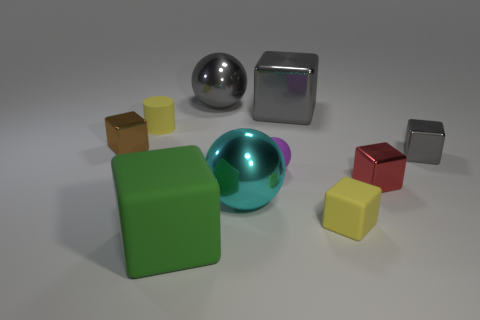What is the material of the yellow object right of the big ball that is in front of the big gray shiny object in front of the big gray sphere?
Keep it short and to the point. Rubber. Is the number of small matte things on the right side of the red metallic cube greater than the number of tiny red things on the left side of the tiny purple rubber ball?
Give a very brief answer. No. Do the purple rubber sphere and the cyan metallic thing have the same size?
Give a very brief answer. No. The other tiny rubber thing that is the same shape as the brown object is what color?
Offer a very short reply. Yellow. What number of small objects have the same color as the large metallic block?
Keep it short and to the point. 1. Are there more yellow cylinders that are to the right of the brown shiny cube than blue cylinders?
Give a very brief answer. Yes. What is the color of the big thing in front of the large sphere in front of the red cube?
Provide a succinct answer. Green. What number of things are either large cubes that are right of the big gray ball or cubes right of the purple matte object?
Your answer should be very brief. 4. What is the color of the small matte cube?
Give a very brief answer. Yellow. How many cubes are made of the same material as the cyan thing?
Offer a very short reply. 4. 